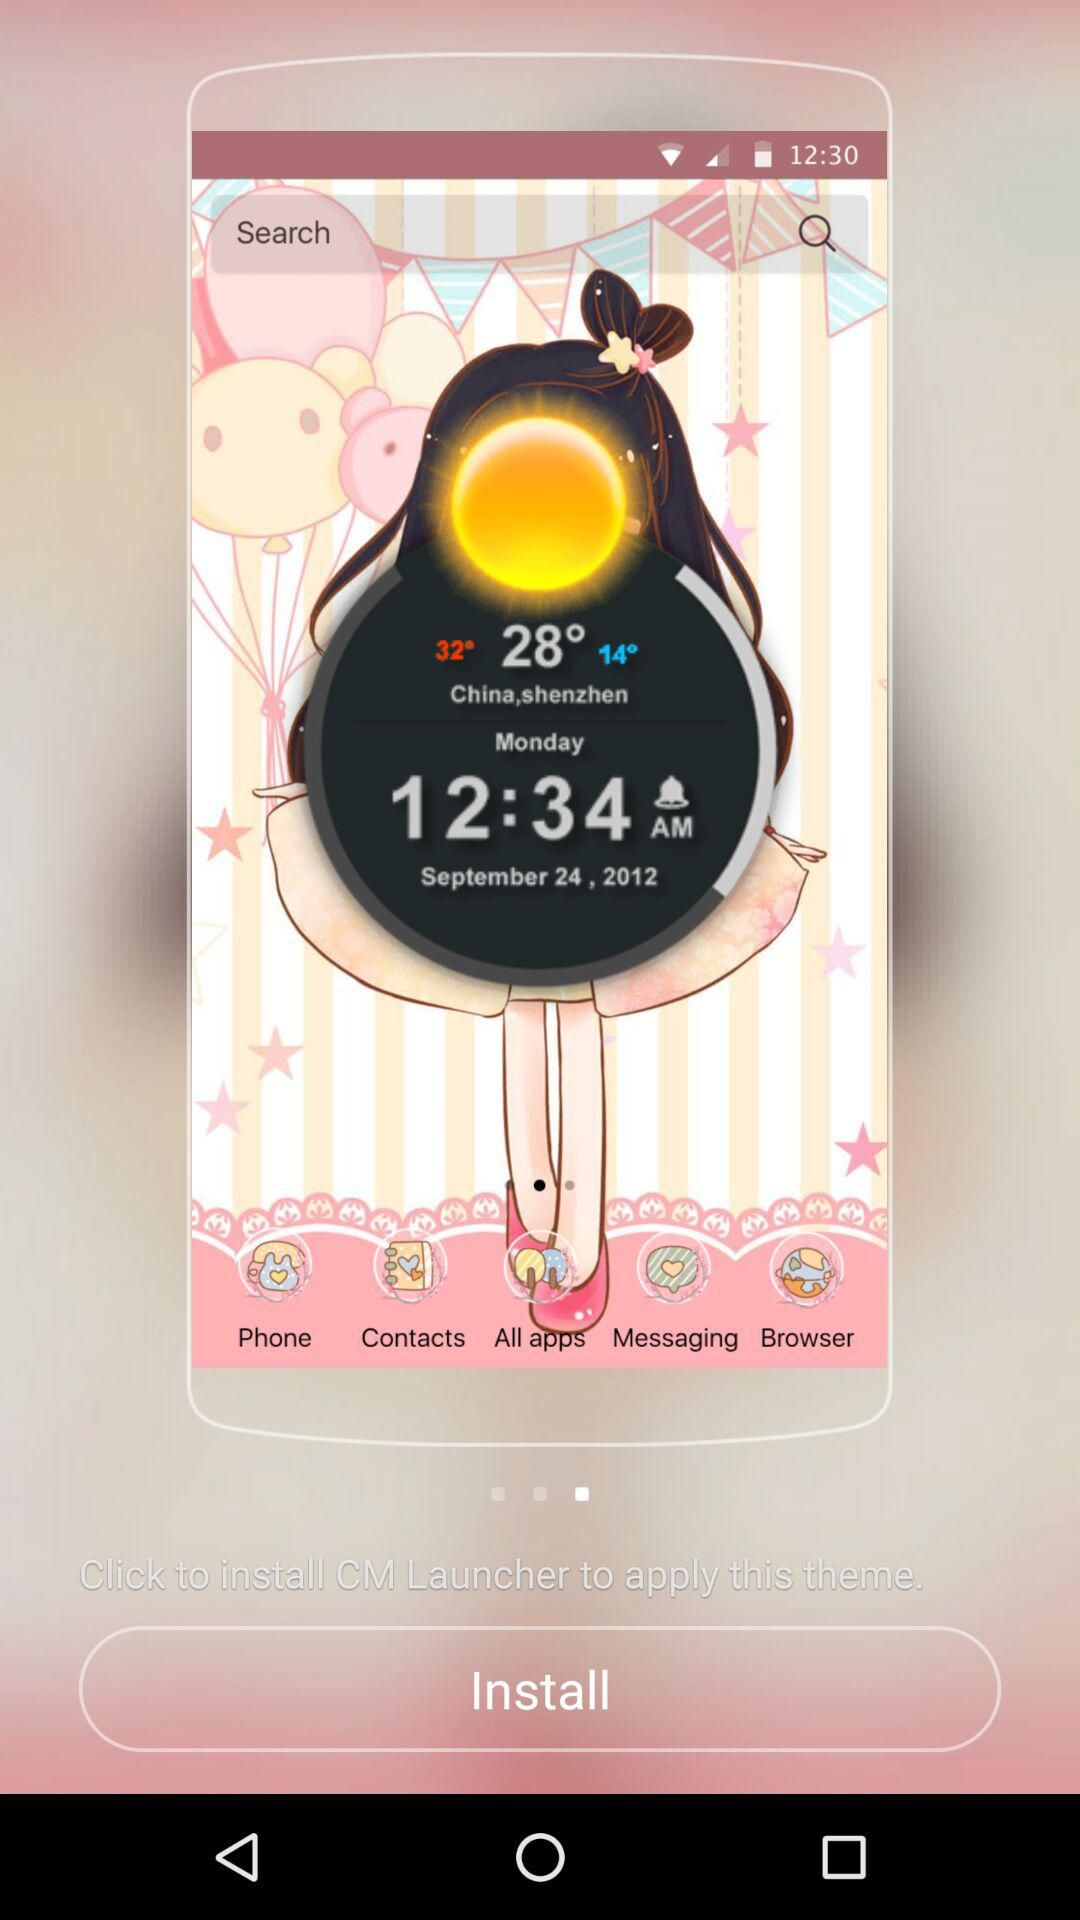What is the given time? The given time is 12:34 AM. 